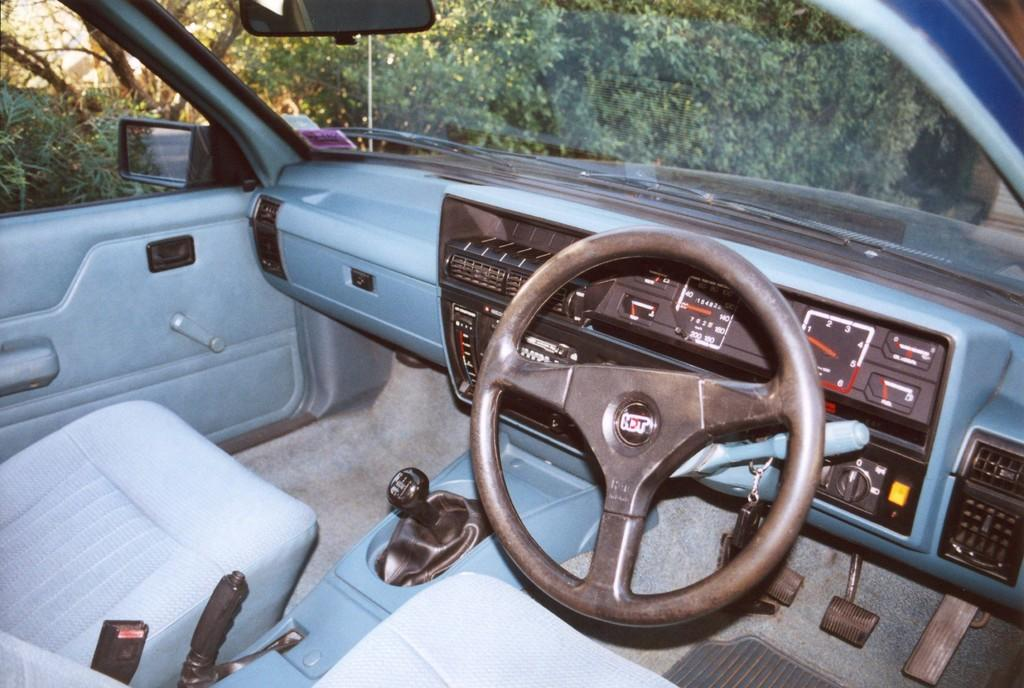What is the main subject of the image? The main subject of the image is a car. What can be seen inside the car? The steering wheel, seats, dashboard, and windshield are visible inside the car. What is visible through the windshield? Trees are visible through the windshield. Can you see a boy climbing a mountain in the image? There is no boy climbing a mountain in the image; it features a car with a view of trees through the windshield. Is there a jail visible in the image? There is no jail present in the image; it features a car with a view of trees through the windshield. 